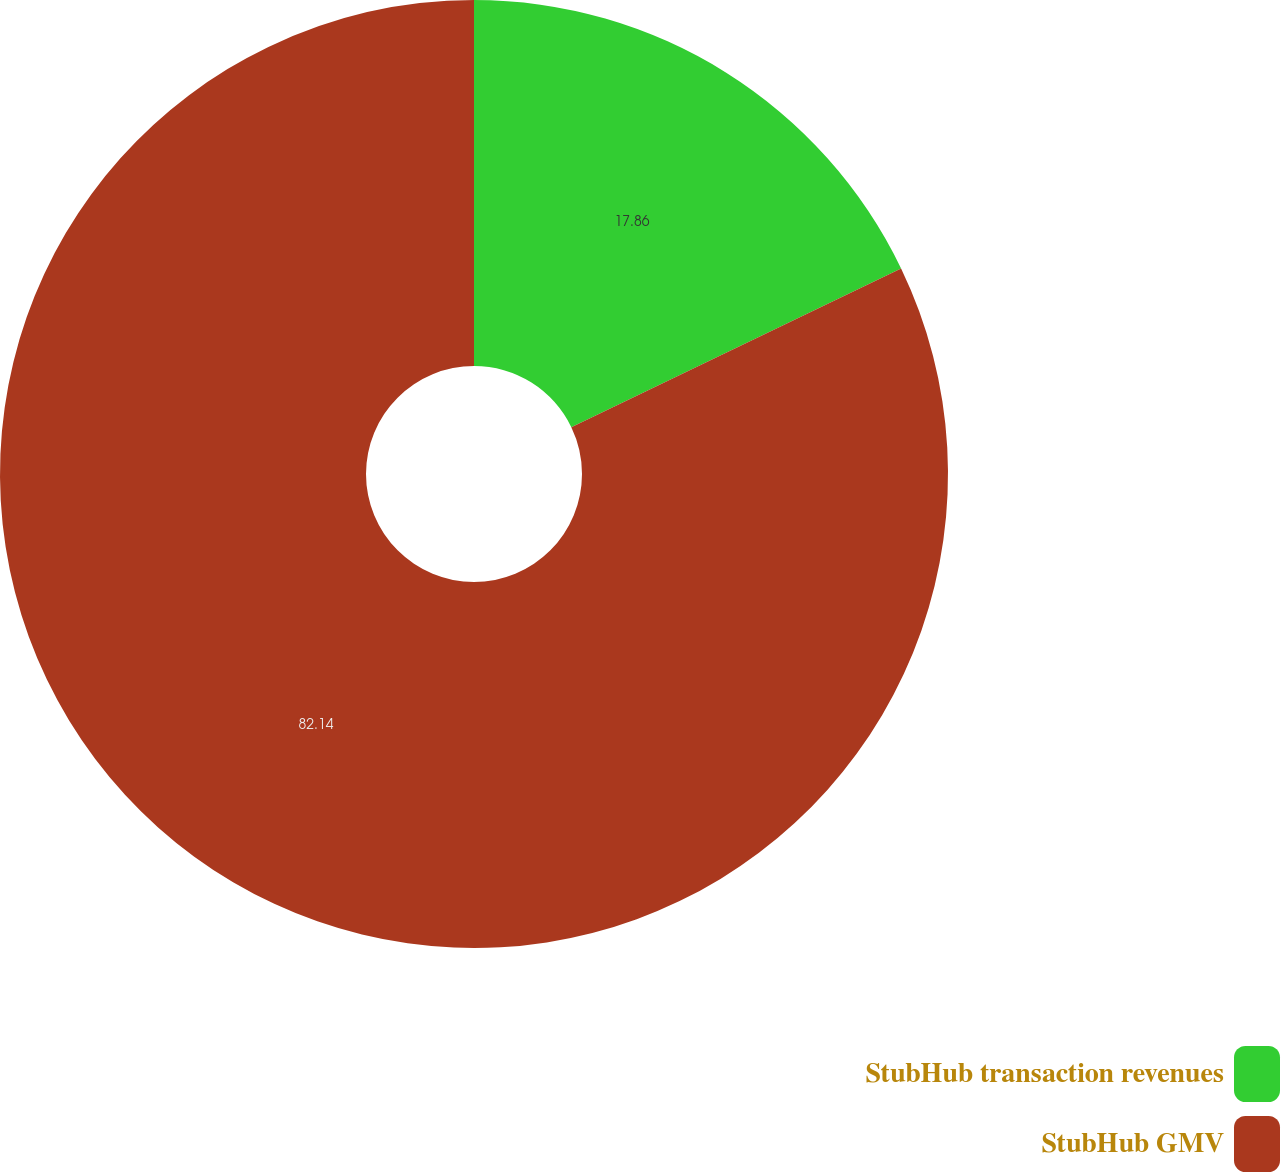<chart> <loc_0><loc_0><loc_500><loc_500><pie_chart><fcel>StubHub transaction revenues<fcel>StubHub GMV<nl><fcel>17.86%<fcel>82.14%<nl></chart> 